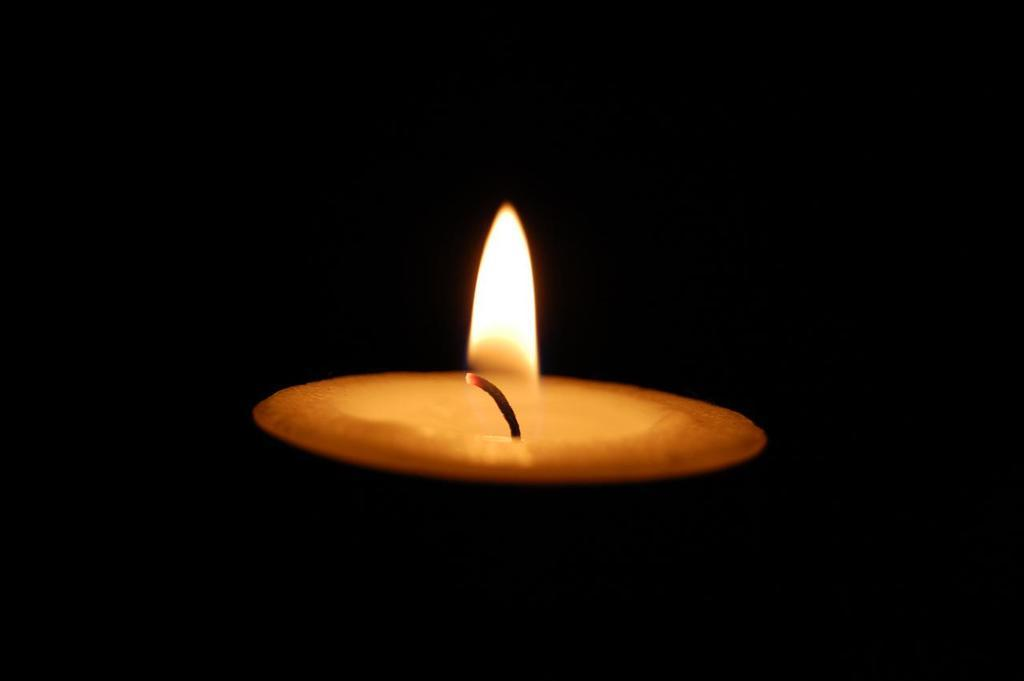What is the main object in the image? There is a small lit candle in the image. What is the state of the candle in the image? The candle is lit in the image. What did mom say about the aftermath of the knife incident in the image? There is no mention of a mom, a knife incident, or any conversation in the image. The image only shows a small lit candle. 